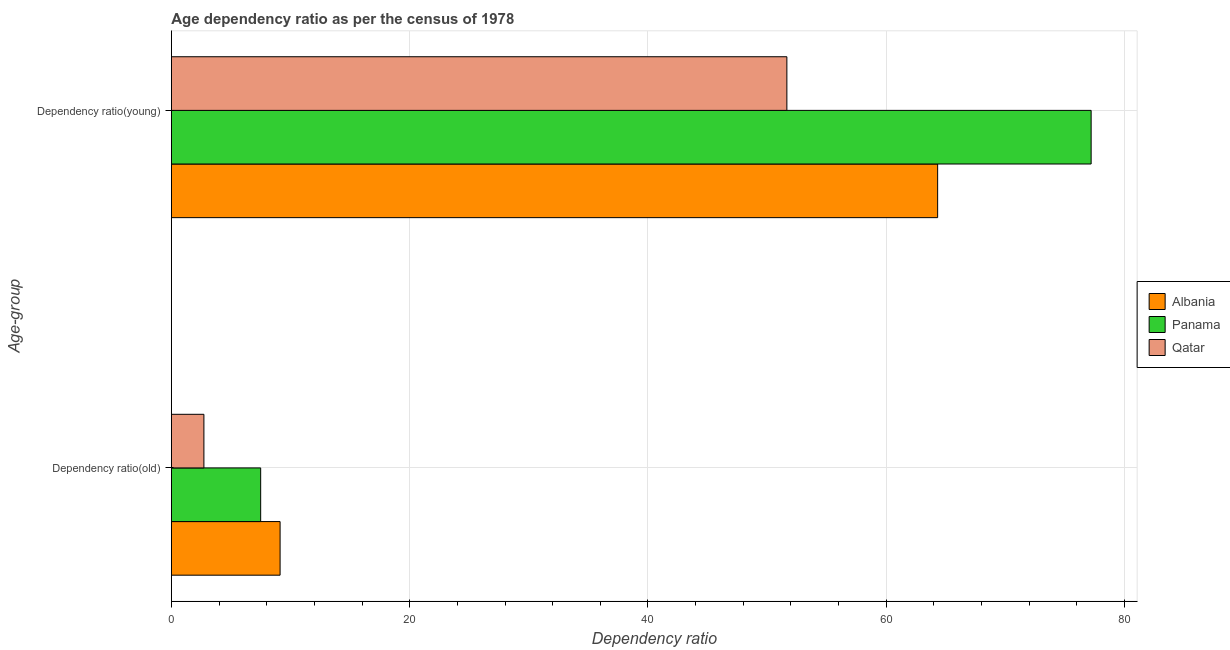How many groups of bars are there?
Ensure brevity in your answer.  2. Are the number of bars on each tick of the Y-axis equal?
Make the answer very short. Yes. How many bars are there on the 1st tick from the top?
Offer a terse response. 3. How many bars are there on the 1st tick from the bottom?
Your answer should be compact. 3. What is the label of the 1st group of bars from the top?
Your answer should be very brief. Dependency ratio(young). What is the age dependency ratio(old) in Albania?
Give a very brief answer. 9.12. Across all countries, what is the maximum age dependency ratio(young)?
Keep it short and to the point. 77.19. Across all countries, what is the minimum age dependency ratio(young)?
Offer a very short reply. 51.66. In which country was the age dependency ratio(young) maximum?
Your answer should be very brief. Panama. In which country was the age dependency ratio(old) minimum?
Your answer should be compact. Qatar. What is the total age dependency ratio(young) in the graph?
Offer a terse response. 193.16. What is the difference between the age dependency ratio(young) in Qatar and that in Albania?
Ensure brevity in your answer.  -12.65. What is the difference between the age dependency ratio(young) in Albania and the age dependency ratio(old) in Panama?
Your answer should be compact. 56.82. What is the average age dependency ratio(young) per country?
Offer a terse response. 64.39. What is the difference between the age dependency ratio(young) and age dependency ratio(old) in Albania?
Your answer should be compact. 55.19. In how many countries, is the age dependency ratio(young) greater than 68 ?
Offer a terse response. 1. What is the ratio of the age dependency ratio(young) in Albania to that in Qatar?
Offer a very short reply. 1.24. Is the age dependency ratio(old) in Panama less than that in Qatar?
Ensure brevity in your answer.  No. What does the 1st bar from the top in Dependency ratio(old) represents?
Ensure brevity in your answer.  Qatar. What does the 1st bar from the bottom in Dependency ratio(old) represents?
Ensure brevity in your answer.  Albania. How many bars are there?
Provide a succinct answer. 6. Are all the bars in the graph horizontal?
Offer a very short reply. Yes. What is the difference between two consecutive major ticks on the X-axis?
Provide a succinct answer. 20. Does the graph contain any zero values?
Ensure brevity in your answer.  No. Does the graph contain grids?
Make the answer very short. Yes. How are the legend labels stacked?
Offer a terse response. Vertical. What is the title of the graph?
Provide a short and direct response. Age dependency ratio as per the census of 1978. What is the label or title of the X-axis?
Make the answer very short. Dependency ratio. What is the label or title of the Y-axis?
Your answer should be very brief. Age-group. What is the Dependency ratio of Albania in Dependency ratio(old)?
Your answer should be compact. 9.12. What is the Dependency ratio in Panama in Dependency ratio(old)?
Offer a very short reply. 7.49. What is the Dependency ratio of Qatar in Dependency ratio(old)?
Give a very brief answer. 2.73. What is the Dependency ratio in Albania in Dependency ratio(young)?
Keep it short and to the point. 64.31. What is the Dependency ratio of Panama in Dependency ratio(young)?
Your response must be concise. 77.19. What is the Dependency ratio in Qatar in Dependency ratio(young)?
Offer a very short reply. 51.66. Across all Age-group, what is the maximum Dependency ratio in Albania?
Provide a succinct answer. 64.31. Across all Age-group, what is the maximum Dependency ratio of Panama?
Keep it short and to the point. 77.19. Across all Age-group, what is the maximum Dependency ratio in Qatar?
Offer a terse response. 51.66. Across all Age-group, what is the minimum Dependency ratio of Albania?
Give a very brief answer. 9.12. Across all Age-group, what is the minimum Dependency ratio in Panama?
Provide a succinct answer. 7.49. Across all Age-group, what is the minimum Dependency ratio of Qatar?
Keep it short and to the point. 2.73. What is the total Dependency ratio in Albania in the graph?
Provide a short and direct response. 73.43. What is the total Dependency ratio of Panama in the graph?
Offer a terse response. 84.69. What is the total Dependency ratio of Qatar in the graph?
Your answer should be compact. 54.39. What is the difference between the Dependency ratio in Albania in Dependency ratio(old) and that in Dependency ratio(young)?
Your answer should be very brief. -55.19. What is the difference between the Dependency ratio in Panama in Dependency ratio(old) and that in Dependency ratio(young)?
Your answer should be compact. -69.7. What is the difference between the Dependency ratio in Qatar in Dependency ratio(old) and that in Dependency ratio(young)?
Keep it short and to the point. -48.93. What is the difference between the Dependency ratio in Albania in Dependency ratio(old) and the Dependency ratio in Panama in Dependency ratio(young)?
Keep it short and to the point. -68.07. What is the difference between the Dependency ratio in Albania in Dependency ratio(old) and the Dependency ratio in Qatar in Dependency ratio(young)?
Offer a very short reply. -42.53. What is the difference between the Dependency ratio of Panama in Dependency ratio(old) and the Dependency ratio of Qatar in Dependency ratio(young)?
Keep it short and to the point. -44.16. What is the average Dependency ratio of Albania per Age-group?
Keep it short and to the point. 36.72. What is the average Dependency ratio in Panama per Age-group?
Your answer should be very brief. 42.34. What is the average Dependency ratio in Qatar per Age-group?
Your response must be concise. 27.19. What is the difference between the Dependency ratio in Albania and Dependency ratio in Panama in Dependency ratio(old)?
Offer a terse response. 1.63. What is the difference between the Dependency ratio of Albania and Dependency ratio of Qatar in Dependency ratio(old)?
Offer a very short reply. 6.39. What is the difference between the Dependency ratio in Panama and Dependency ratio in Qatar in Dependency ratio(old)?
Your answer should be very brief. 4.76. What is the difference between the Dependency ratio in Albania and Dependency ratio in Panama in Dependency ratio(young)?
Ensure brevity in your answer.  -12.88. What is the difference between the Dependency ratio in Albania and Dependency ratio in Qatar in Dependency ratio(young)?
Offer a very short reply. 12.65. What is the difference between the Dependency ratio in Panama and Dependency ratio in Qatar in Dependency ratio(young)?
Ensure brevity in your answer.  25.54. What is the ratio of the Dependency ratio of Albania in Dependency ratio(old) to that in Dependency ratio(young)?
Your response must be concise. 0.14. What is the ratio of the Dependency ratio in Panama in Dependency ratio(old) to that in Dependency ratio(young)?
Provide a succinct answer. 0.1. What is the ratio of the Dependency ratio in Qatar in Dependency ratio(old) to that in Dependency ratio(young)?
Give a very brief answer. 0.05. What is the difference between the highest and the second highest Dependency ratio in Albania?
Offer a terse response. 55.19. What is the difference between the highest and the second highest Dependency ratio in Panama?
Give a very brief answer. 69.7. What is the difference between the highest and the second highest Dependency ratio of Qatar?
Offer a very short reply. 48.93. What is the difference between the highest and the lowest Dependency ratio in Albania?
Keep it short and to the point. 55.19. What is the difference between the highest and the lowest Dependency ratio of Panama?
Your answer should be compact. 69.7. What is the difference between the highest and the lowest Dependency ratio of Qatar?
Your answer should be compact. 48.93. 